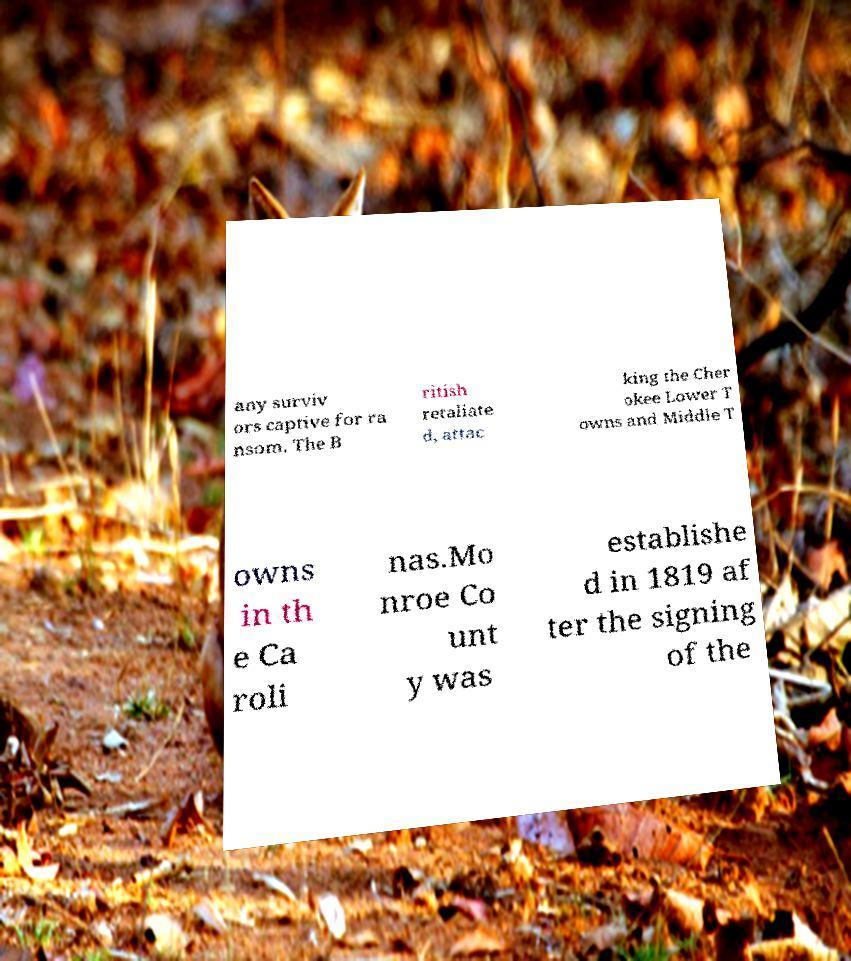Can you accurately transcribe the text from the provided image for me? any surviv ors captive for ra nsom. The B ritish retaliate d, attac king the Cher okee Lower T owns and Middle T owns in th e Ca roli nas.Mo nroe Co unt y was establishe d in 1819 af ter the signing of the 